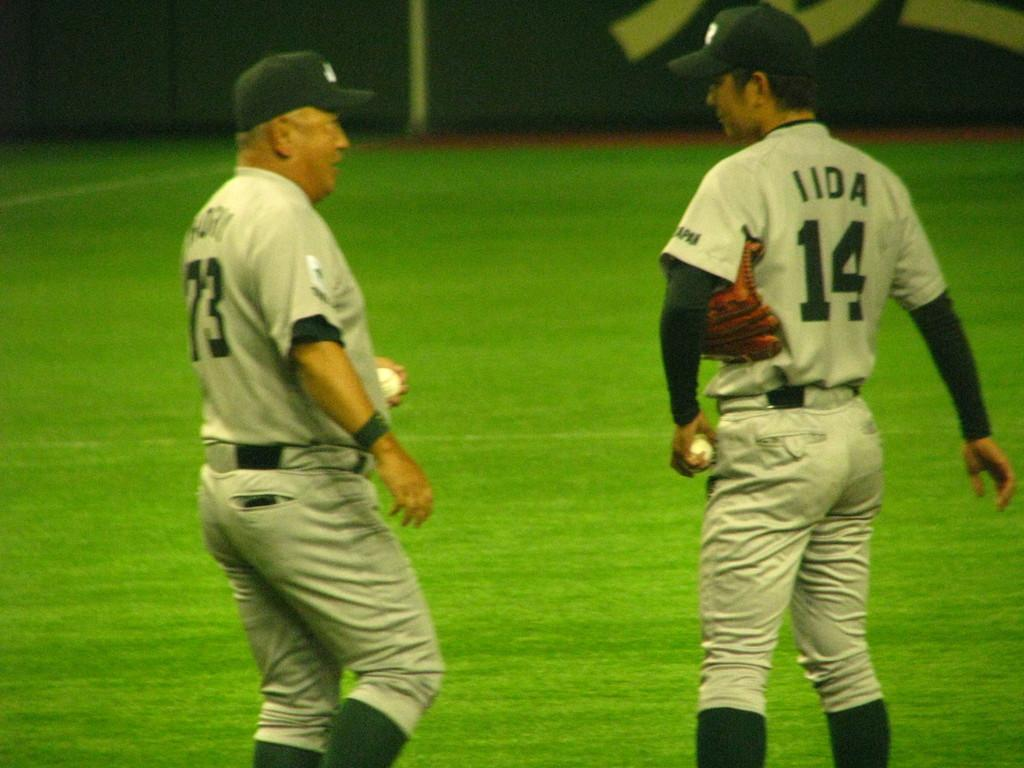How many people are in the image? There are two persons in the image. What are the persons doing in the image? The persons are standing on the ground and holding a ball in their hands. What type of fruit is being processed by the persons in the image? There is no fruit or processing activity present in the image; the persons are simply holding a ball. 